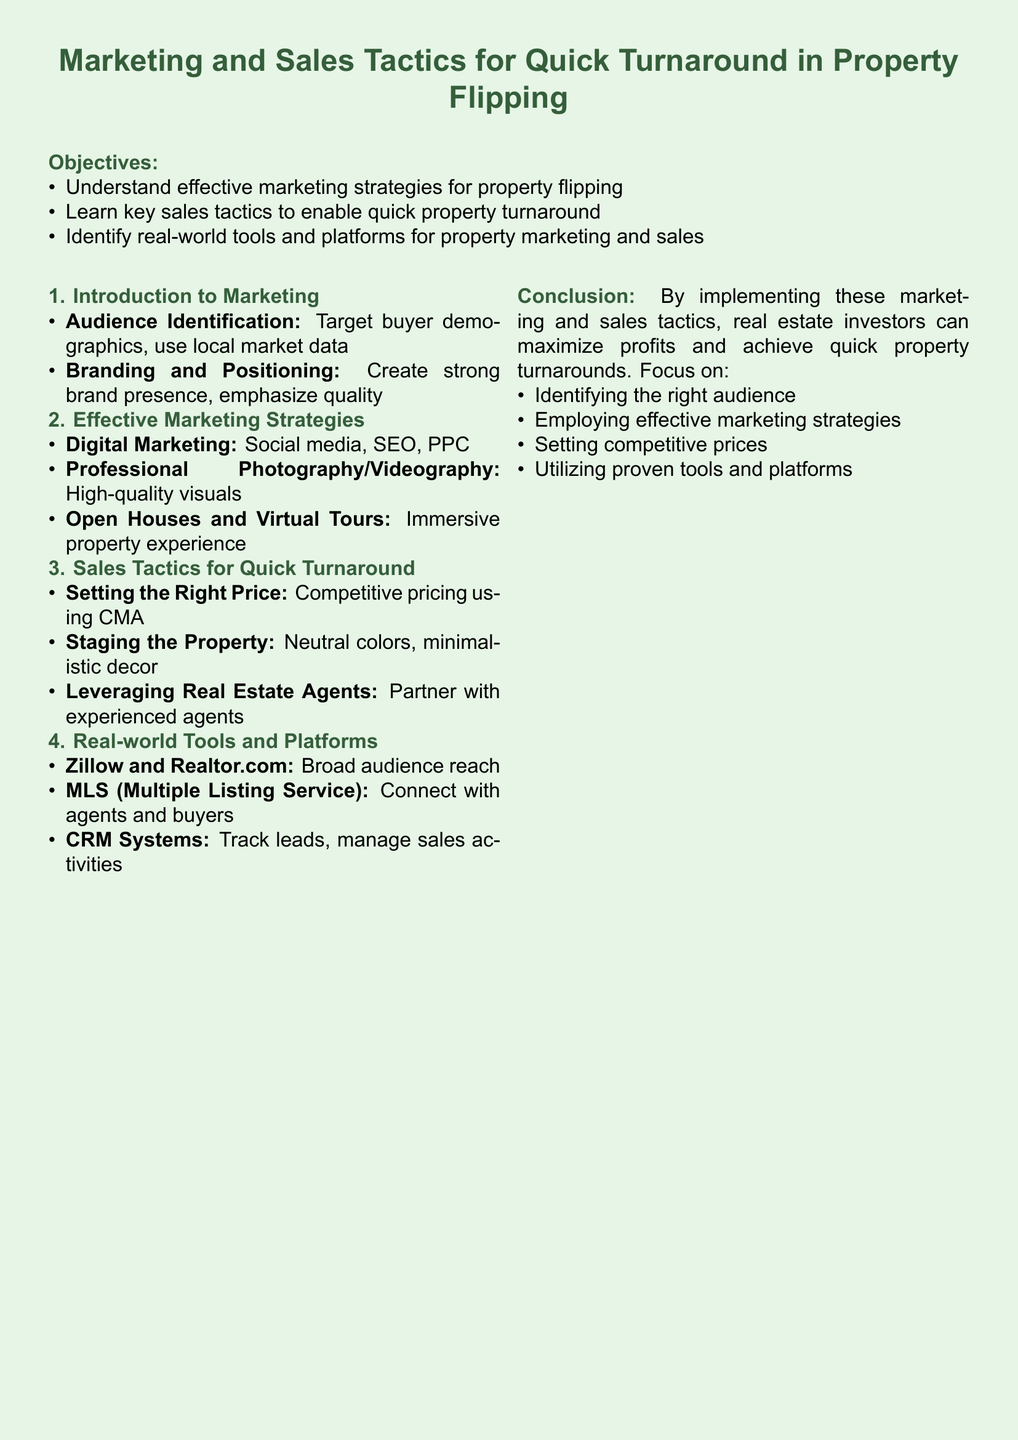what is the main focus of the lesson plan? The lesson plan focuses on marketing and sales tactics for quick turnaround in property flipping.
Answer: marketing and sales tactics for quick turnaround in property flipping how many objectives are listed in the document? There are four objectives listed in the document, which outline what participants will learn.
Answer: four what digital marketing strategies are mentioned? The document mentions social media, SEO, and PPC as digital marketing strategies.
Answer: social media, SEO, PPC what is one key sales tactic for property flipping? One key sales tactic mentioned is setting the right price using CMA.
Answer: setting the right price using CMA which platforms are identified for property marketing? Zillow, Realtor.com, and MLS are identified as platforms for property marketing.
Answer: Zillow, Realtor.com, MLS what should be emphasized in branding according to the document? The document emphasizes creating a strong brand presence and quality in branding.
Answer: strong brand presence, quality how can open houses be enhanced? The document suggests using immersive property experiences such as virtual tours to enhance open houses.
Answer: immersive property experiences, virtual tours who can real estate investors partner with for quicker sales? Real estate investors can partner with experienced agents for quicker sales.
Answer: experienced agents 